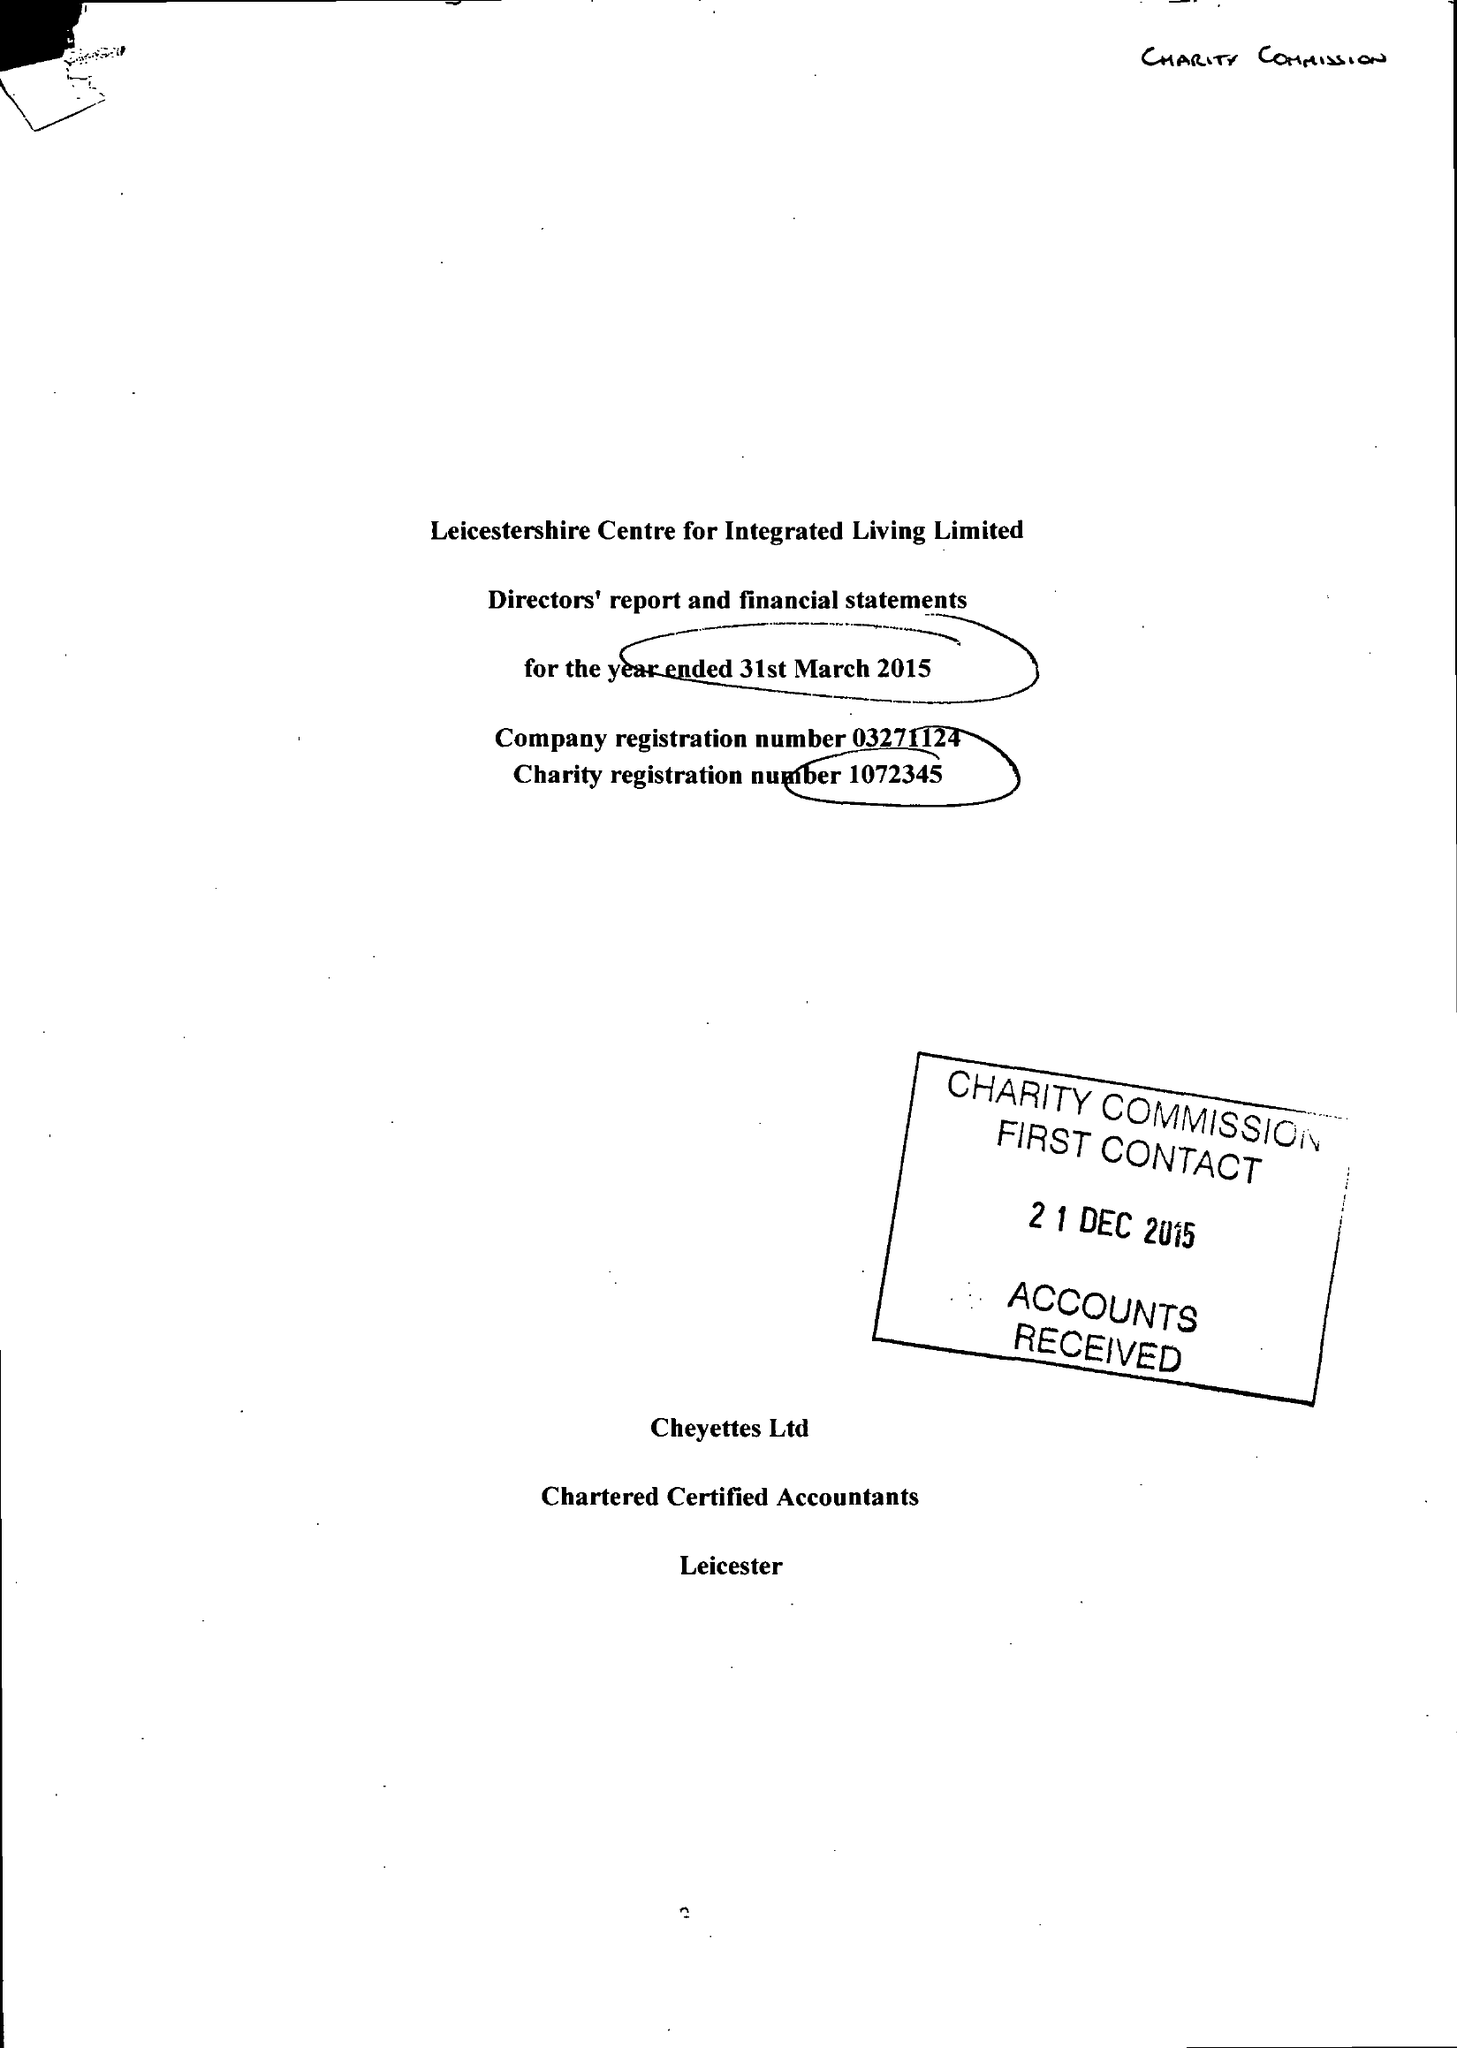What is the value for the income_annually_in_british_pounds?
Answer the question using a single word or phrase. 62326.00 